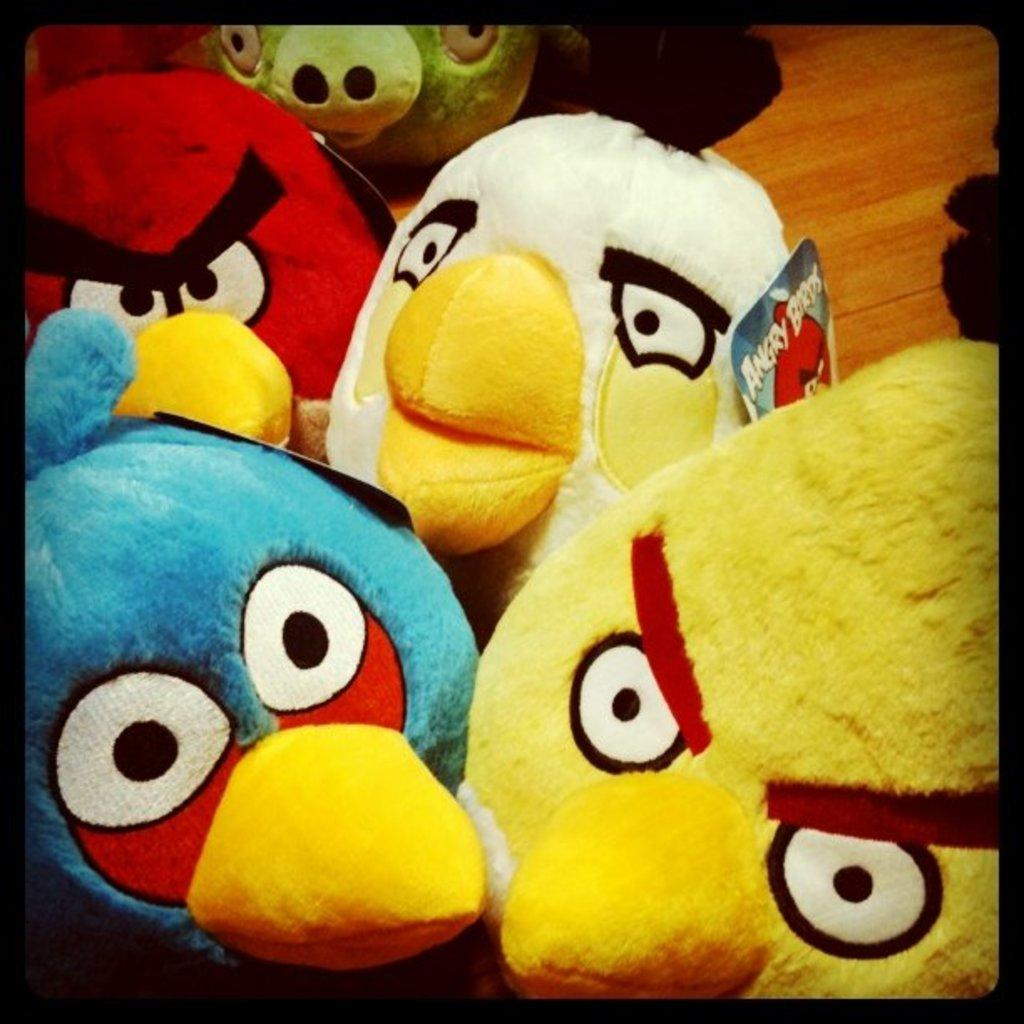What type of toys are in the image? There are angry birds toys in the image. Are there any additional features on the toys? Yes, the toys have tags. What type of surface is the toys placed on? The toys are on a wooden floor. What show is the angry birds toys watching in the image? There is no indication in the image that the toys are watching a show. --- Facts: 1. There is a person holding a camera in the image. 2. The person is wearing a hat. 3. The background of the image is a cityscape. Absurd Topics: dance, swim, mountain Conversation: What is the person in the image doing? The person is holding a camera in the image. What type of clothing is the person wearing? The person is wearing a hat. What can be seen in the background of the image? The background of the image is a cityscape. Reasoning: Let's think step by step in order to produce the conversation. We start by identifying the main subject in the image, which is the person holding a camera. Then, we expand the conversation to include other details about the person, such as the hat they are wearing. Finally, we describe the background of the image, which is a cityscape. Absurd Question/Answer: Can you see the person swimming in the image? No, there is no indication in the image that the person is swimming. --- Facts: 1. There is a person sitting on a bench in the image. 2. The person is reading a book. 3. There is a tree in the background of the image. Absurd Topics: elephant, piano, concert Conversation: What is the person in the image doing? The person is sitting on a bench in the image. What is the person holding or interacting with in the image? The person is reading a book in the image. What can be seen in the background of the image? There is a tree in the background of the image. Reasoning: Let's think step by step in order to produce the conversation. We start by identifying the main subject in the image, which is the person sitting on a bench. Next, we describe what the person is holding or interacting with, which is a book. Finally, we describe what can be seen in the background of the image, which is a tree. Absurd Question/Answer: What type of elephant can be seen playing the piano in the image? There is no elephant or piano present in the image. --- Facts: 1. There is a person sitting on a bench in the image. 2. The person is sitting on a bench in the image. 3. There is a tree in the background of the image. Absurd Topics: elephant, piano, concert Conversation: 